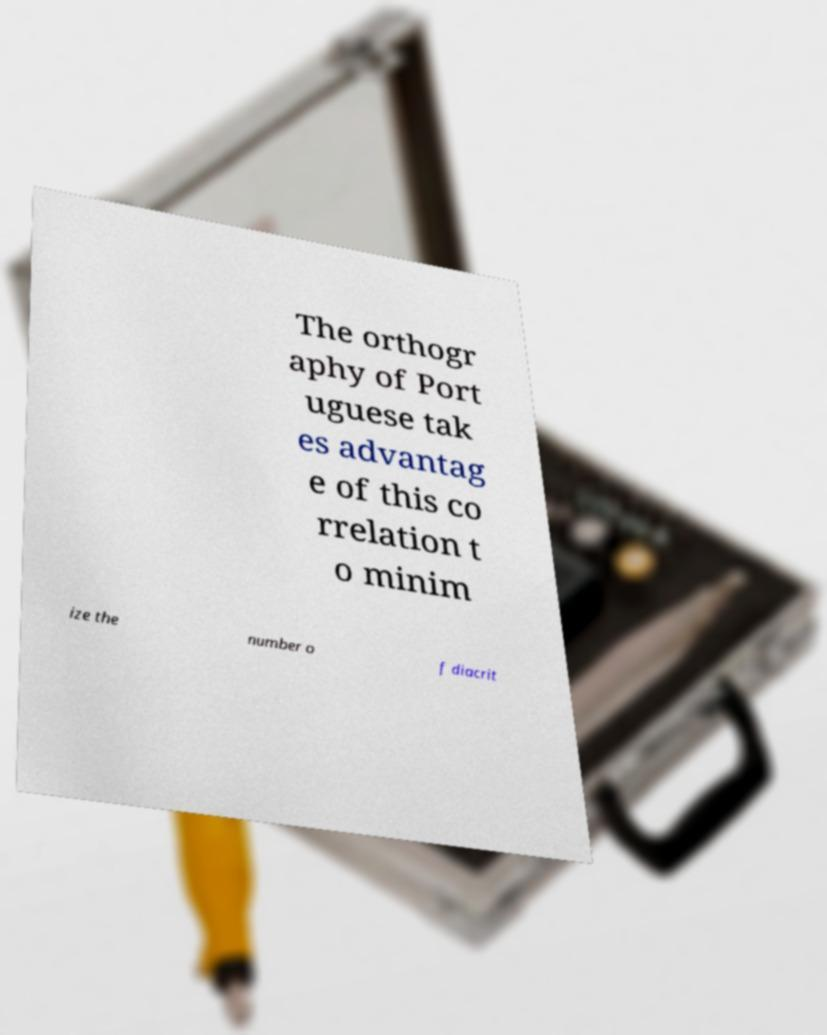Can you accurately transcribe the text from the provided image for me? The orthogr aphy of Port uguese tak es advantag e of this co rrelation t o minim ize the number o f diacrit 